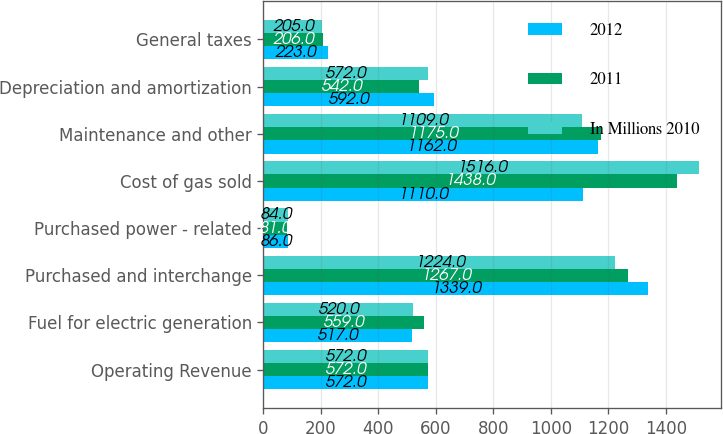<chart> <loc_0><loc_0><loc_500><loc_500><stacked_bar_chart><ecel><fcel>Operating Revenue<fcel>Fuel for electric generation<fcel>Purchased and interchange<fcel>Purchased power - related<fcel>Cost of gas sold<fcel>Maintenance and other<fcel>Depreciation and amortization<fcel>General taxes<nl><fcel>2012<fcel>572<fcel>517<fcel>1339<fcel>86<fcel>1110<fcel>1162<fcel>592<fcel>223<nl><fcel>2011<fcel>572<fcel>559<fcel>1267<fcel>81<fcel>1438<fcel>1175<fcel>542<fcel>206<nl><fcel>In Millions 2010<fcel>572<fcel>520<fcel>1224<fcel>84<fcel>1516<fcel>1109<fcel>572<fcel>205<nl></chart> 